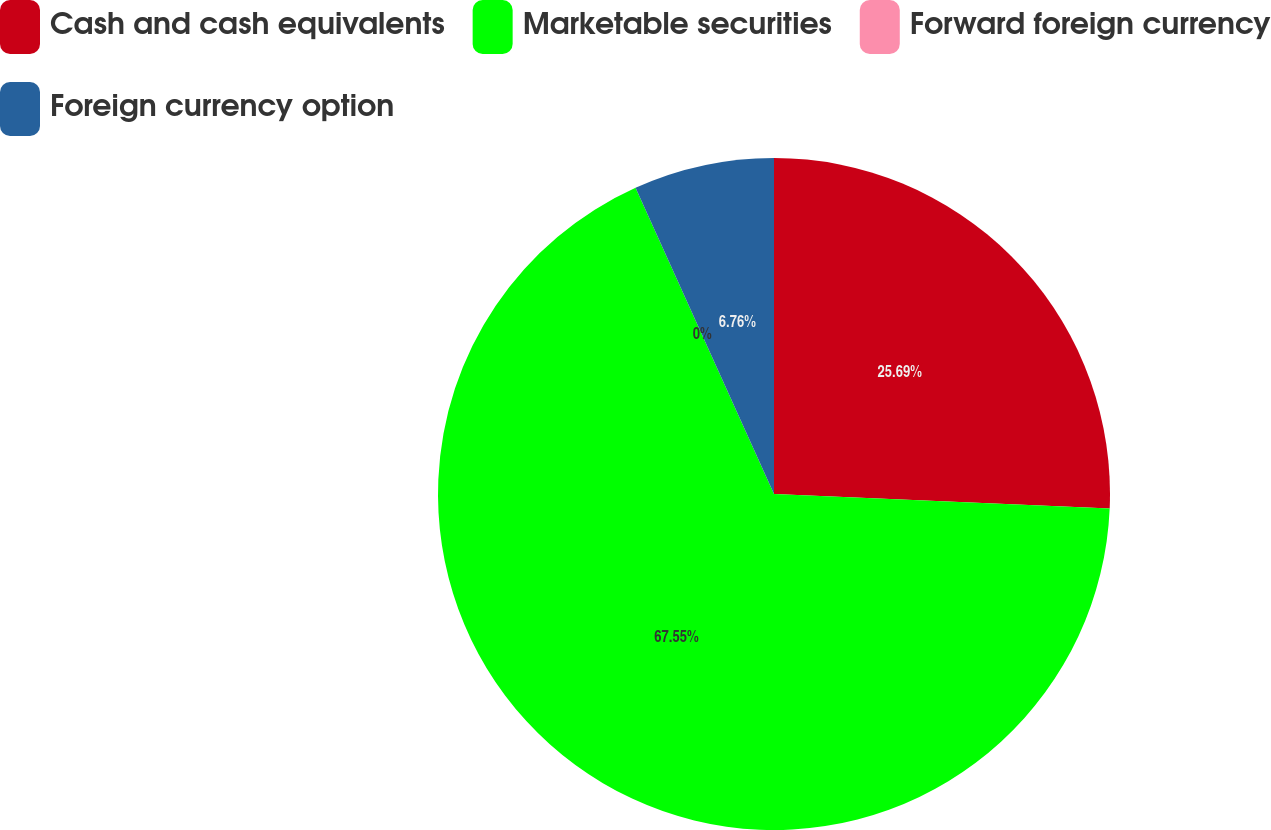Convert chart to OTSL. <chart><loc_0><loc_0><loc_500><loc_500><pie_chart><fcel>Cash and cash equivalents<fcel>Marketable securities<fcel>Forward foreign currency<fcel>Foreign currency option<nl><fcel>25.69%<fcel>67.55%<fcel>0.0%<fcel>6.76%<nl></chart> 